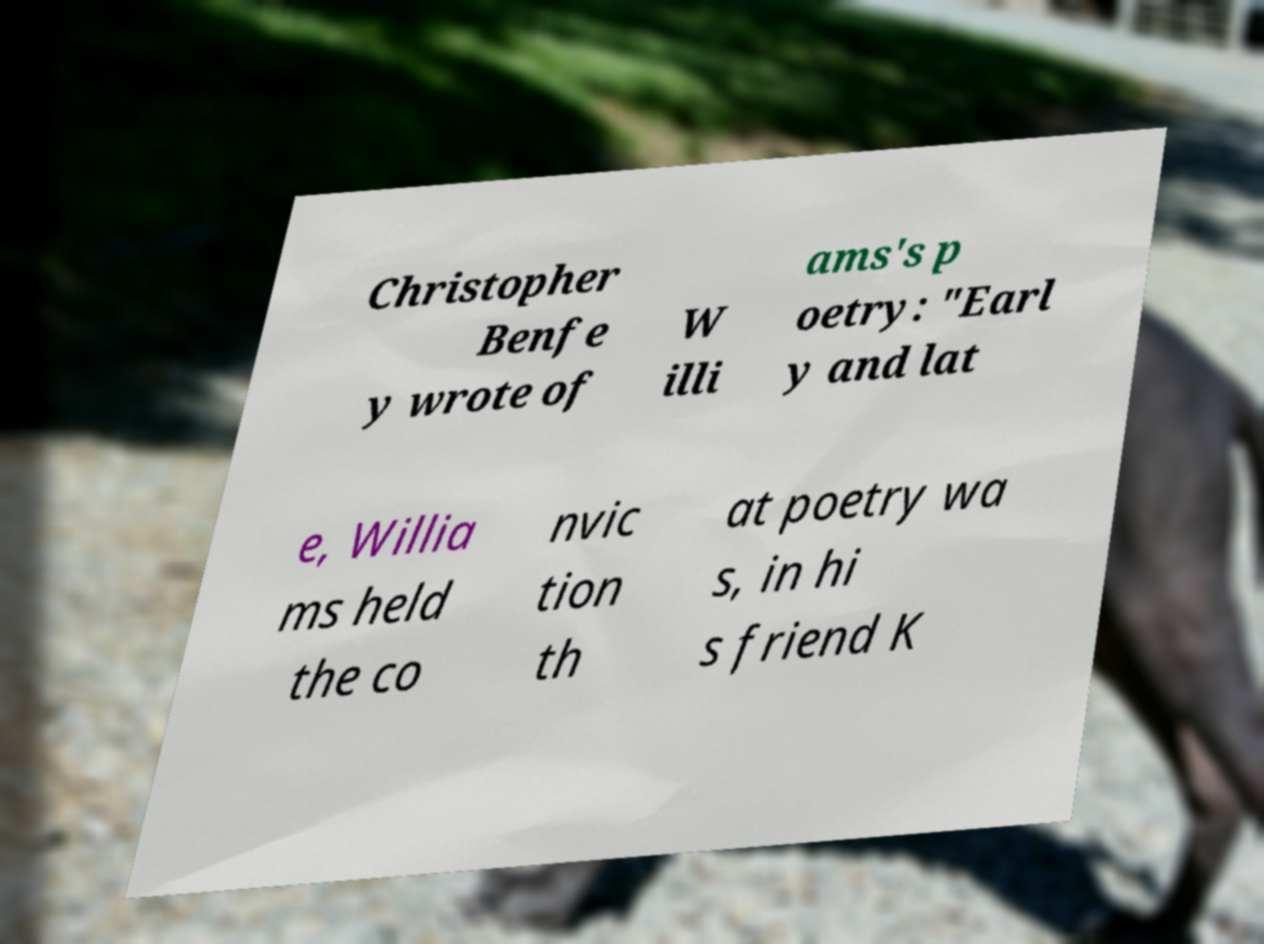Can you accurately transcribe the text from the provided image for me? Christopher Benfe y wrote of W illi ams's p oetry: "Earl y and lat e, Willia ms held the co nvic tion th at poetry wa s, in hi s friend K 